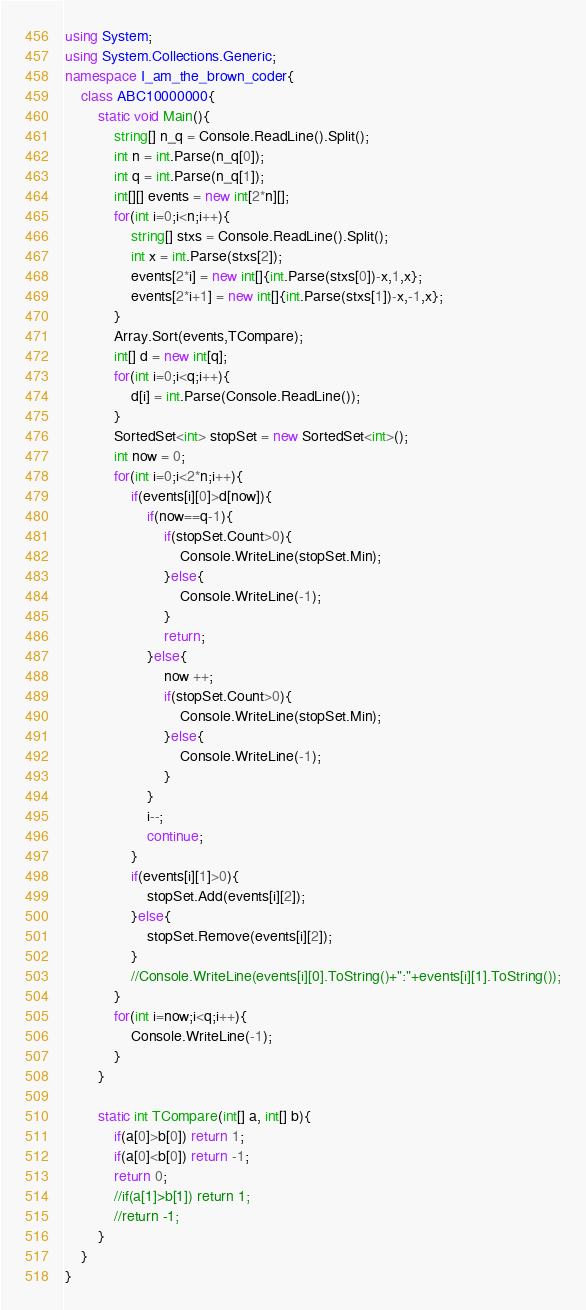Convert code to text. <code><loc_0><loc_0><loc_500><loc_500><_C#_>using System;
using System.Collections.Generic;
namespace I_am_the_brown_coder{
    class ABC10000000{
        static void Main(){
            string[] n_q = Console.ReadLine().Split();
            int n = int.Parse(n_q[0]);
            int q = int.Parse(n_q[1]);
            int[][] events = new int[2*n][];
            for(int i=0;i<n;i++){
                string[] stxs = Console.ReadLine().Split();
                int x = int.Parse(stxs[2]);
                events[2*i] = new int[]{int.Parse(stxs[0])-x,1,x};
                events[2*i+1] = new int[]{int.Parse(stxs[1])-x,-1,x};
            }
            Array.Sort(events,TCompare);
            int[] d = new int[q];
            for(int i=0;i<q;i++){
                d[i] = int.Parse(Console.ReadLine());
            }
            SortedSet<int> stopSet = new SortedSet<int>();
            int now = 0;
            for(int i=0;i<2*n;i++){
                if(events[i][0]>d[now]){
                    if(now==q-1){
                        if(stopSet.Count>0){
                            Console.WriteLine(stopSet.Min);
                        }else{
                            Console.WriteLine(-1);
                        }
                        return;
                    }else{
                        now ++;
                        if(stopSet.Count>0){
                            Console.WriteLine(stopSet.Min);
                        }else{
                            Console.WriteLine(-1);
                        }
                    }
                    i--;
                    continue;
                }
                if(events[i][1]>0){
                    stopSet.Add(events[i][2]);
                }else{
                    stopSet.Remove(events[i][2]);
                }
                //Console.WriteLine(events[i][0].ToString()+":"+events[i][1].ToString());
            }
            for(int i=now;i<q;i++){
                Console.WriteLine(-1);
            }
        }

        static int TCompare(int[] a, int[] b){
            if(a[0]>b[0]) return 1;
            if(a[0]<b[0]) return -1;
            return 0;
            //if(a[1]>b[1]) return 1;
            //return -1;
        }
    }
}</code> 